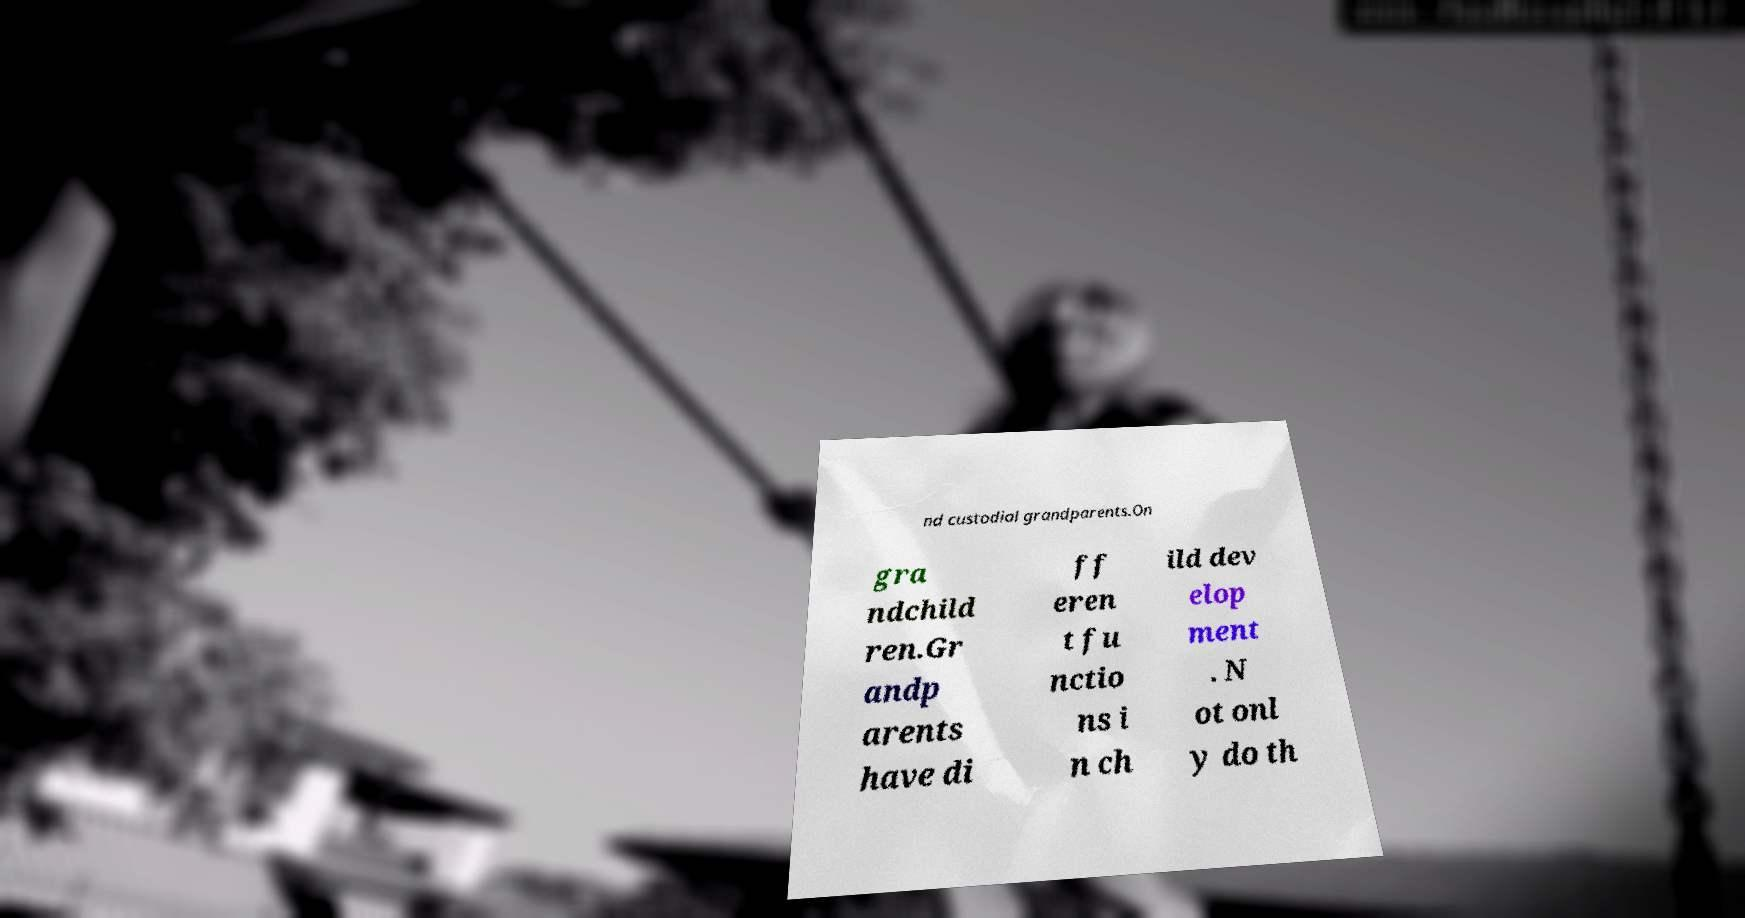There's text embedded in this image that I need extracted. Can you transcribe it verbatim? nd custodial grandparents.On gra ndchild ren.Gr andp arents have di ff eren t fu nctio ns i n ch ild dev elop ment . N ot onl y do th 